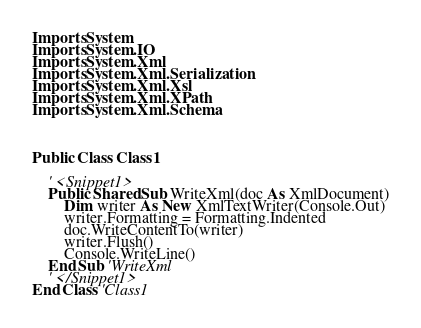<code> <loc_0><loc_0><loc_500><loc_500><_VisualBasic_>Imports System
Imports System.IO
Imports System.Xml
Imports System.Xml.Serialization
Imports System.Xml.Xsl
Imports System.Xml.XPath
Imports System.Xml.Schema



Public Class Class1
    
    ' <Snippet1>
    Public Shared Sub WriteXml(doc As XmlDocument)
        Dim writer As New XmlTextWriter(Console.Out)
        writer.Formatting = Formatting.Indented
        doc.WriteContentTo(writer)
        writer.Flush()
        Console.WriteLine()
    End Sub 'WriteXml
    ' </Snippet1>
End Class 'Class1 
</code> 